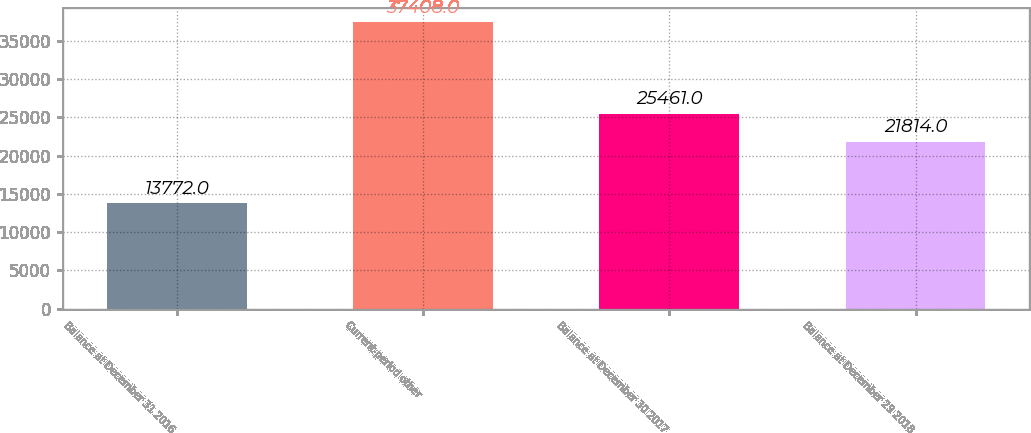<chart> <loc_0><loc_0><loc_500><loc_500><bar_chart><fcel>Balance at December 31 2016<fcel>Current-period other<fcel>Balance at December 30 2017<fcel>Balance at December 29 2018<nl><fcel>13772<fcel>37408<fcel>25461<fcel>21814<nl></chart> 